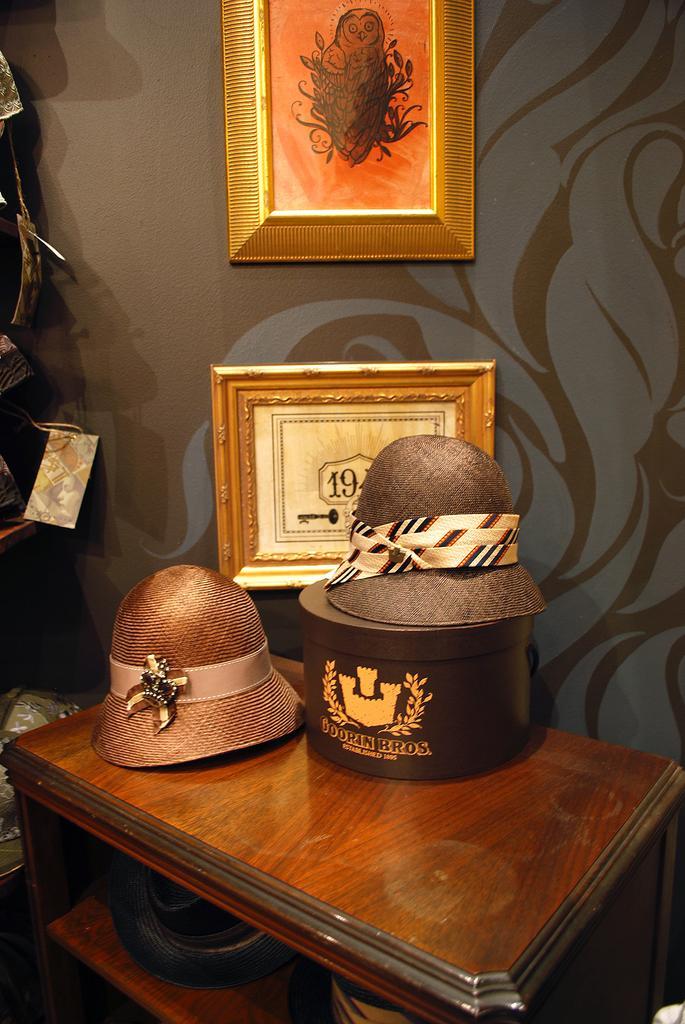Can you describe this image briefly? In this image we can see a photo on the wall. There are few objects placed on the wooden object. There are many objects at the left side of the image. There are few hats in the image. 